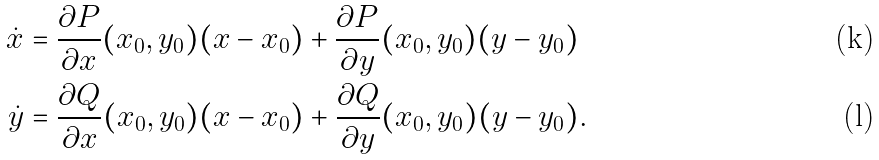<formula> <loc_0><loc_0><loc_500><loc_500>\dot { x } & = \frac { \partial P } { \partial x } ( x _ { 0 } , y _ { 0 } ) ( x - x _ { 0 } ) + \frac { \partial P } { \partial y } ( x _ { 0 } , y _ { 0 } ) ( y - y _ { 0 } ) \\ \dot { y } & = \frac { \partial Q } { \partial x } ( x _ { 0 } , y _ { 0 } ) ( x - x _ { 0 } ) + \frac { \partial Q } { \partial y } ( x _ { 0 } , y _ { 0 } ) ( y - y _ { 0 } ) .</formula> 